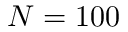<formula> <loc_0><loc_0><loc_500><loc_500>N = 1 0 0</formula> 